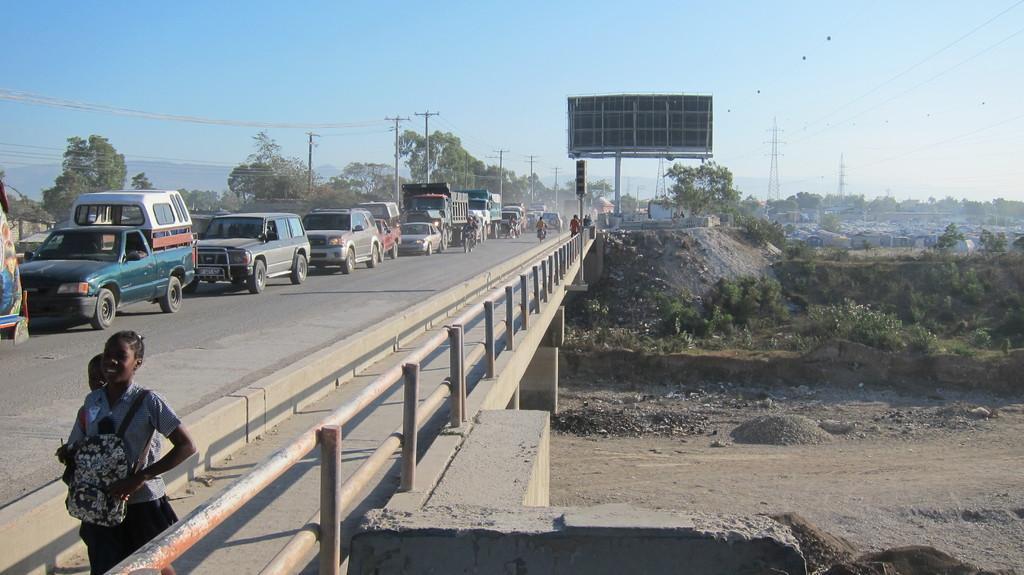Please provide a concise description of this image. In this given image, We can see a bridge and a boundary which is build with an iron metal and there is a huge traffic jam towards the left hand side, We can see couple of electrical poles including wires, certain trees, mountains, sky after that, We can see a hoarding, a traffic signal pole and under the bridge, We can see an electrical towers including wires , couple of trees, towards left bottom, We can see two children carrying a bag and walking. 